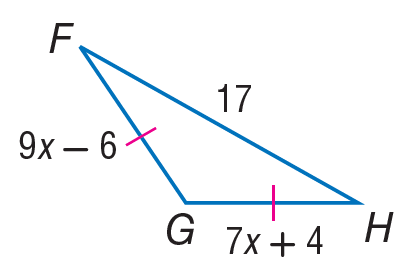Answer the mathemtical geometry problem and directly provide the correct option letter.
Question: Find x.
Choices: A: 4 B: 5 C: 7 D: 17 B 